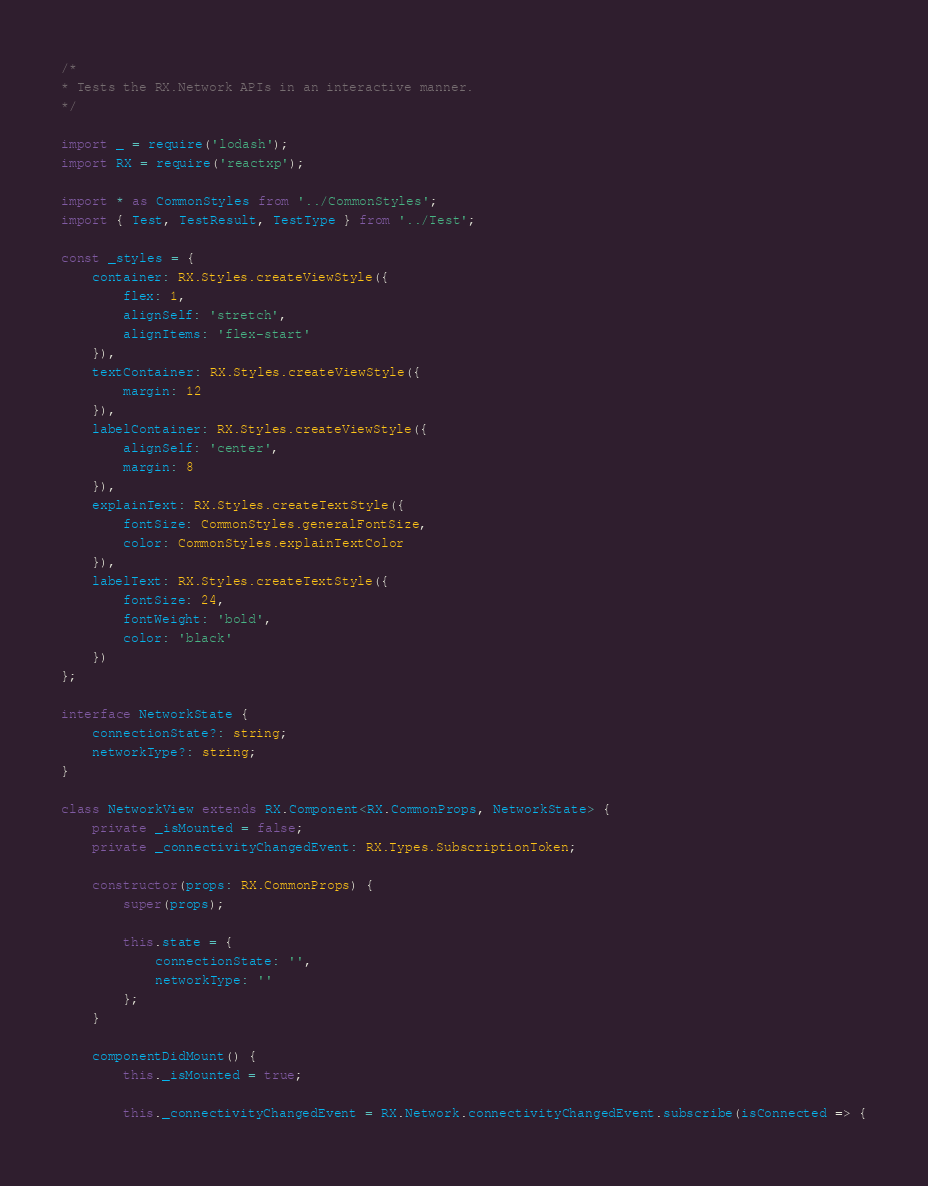Convert code to text. <code><loc_0><loc_0><loc_500><loc_500><_TypeScript_>/*
* Tests the RX.Network APIs in an interactive manner.
*/

import _ = require('lodash');
import RX = require('reactxp');

import * as CommonStyles from '../CommonStyles';
import { Test, TestResult, TestType } from '../Test';

const _styles = {
    container: RX.Styles.createViewStyle({
        flex: 1,
        alignSelf: 'stretch',
        alignItems: 'flex-start'
    }),
    textContainer: RX.Styles.createViewStyle({
        margin: 12
    }),
    labelContainer: RX.Styles.createViewStyle({
        alignSelf: 'center',
        margin: 8
    }),
    explainText: RX.Styles.createTextStyle({
        fontSize: CommonStyles.generalFontSize,
        color: CommonStyles.explainTextColor
    }),
    labelText: RX.Styles.createTextStyle({
        fontSize: 24,
        fontWeight: 'bold',
        color: 'black'
    })
};

interface NetworkState {
    connectionState?: string;
    networkType?: string;
}

class NetworkView extends RX.Component<RX.CommonProps, NetworkState> {
    private _isMounted = false;
    private _connectivityChangedEvent: RX.Types.SubscriptionToken;

    constructor(props: RX.CommonProps) {
        super(props);

        this.state = {
            connectionState: '',
            networkType: ''
        };
    }

    componentDidMount() {
        this._isMounted = true;

        this._connectivityChangedEvent = RX.Network.connectivityChangedEvent.subscribe(isConnected => {</code> 